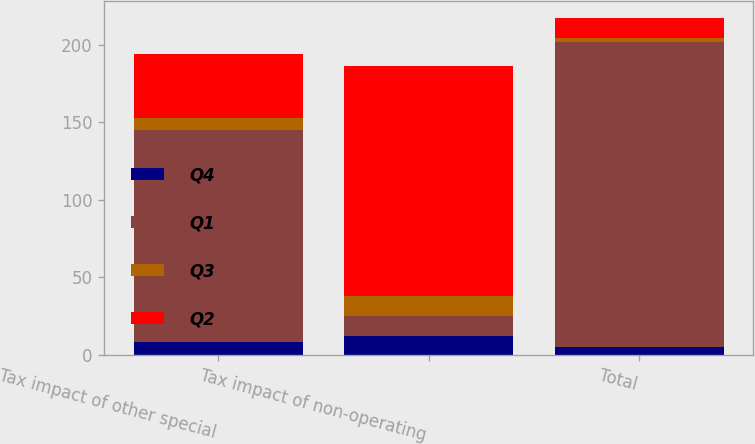Convert chart to OTSL. <chart><loc_0><loc_0><loc_500><loc_500><stacked_bar_chart><ecel><fcel>Tax impact of other special<fcel>Tax impact of non-operating<fcel>Total<nl><fcel>Q4<fcel>8<fcel>12<fcel>5<nl><fcel>Q1<fcel>137<fcel>13<fcel>197<nl><fcel>Q3<fcel>8<fcel>13<fcel>2<nl><fcel>Q2<fcel>41<fcel>148<fcel>13<nl></chart> 